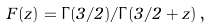Convert formula to latex. <formula><loc_0><loc_0><loc_500><loc_500>F ( z ) = \Gamma ( 3 / 2 ) / \Gamma ( 3 / 2 + z ) \, ,</formula> 